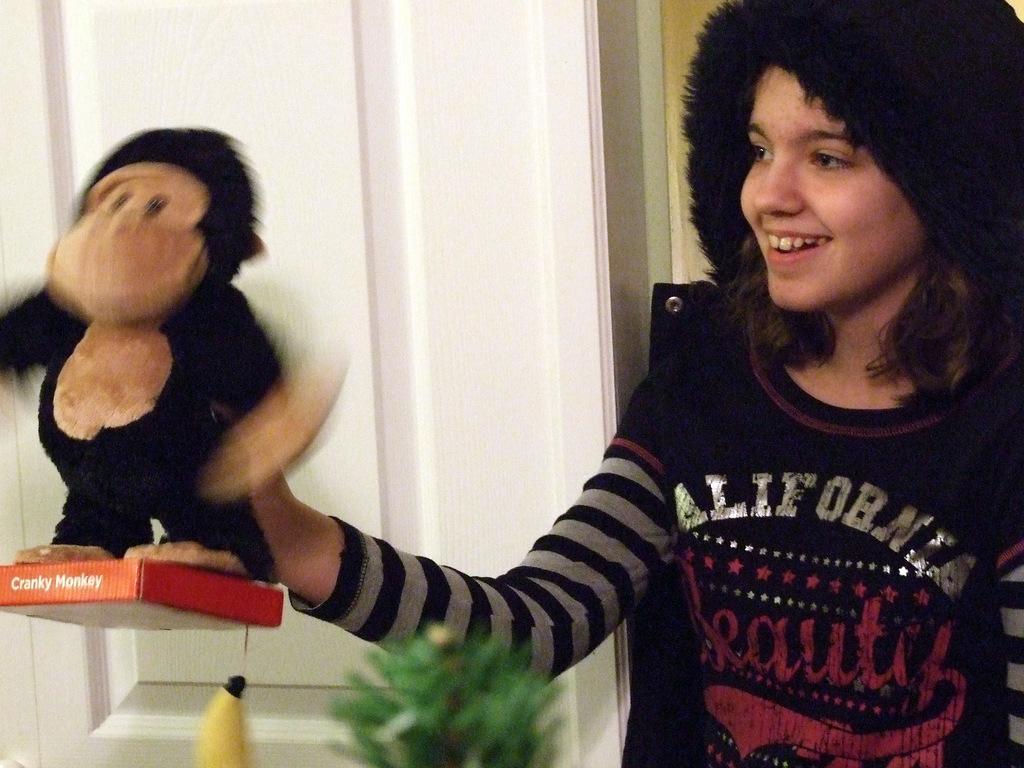Could you give a brief overview of what you see in this image? In this image, we can see a person smiling and wearing a cap and holding a toy. In the background, there is a wall and we can see a plant and a box and an object. 